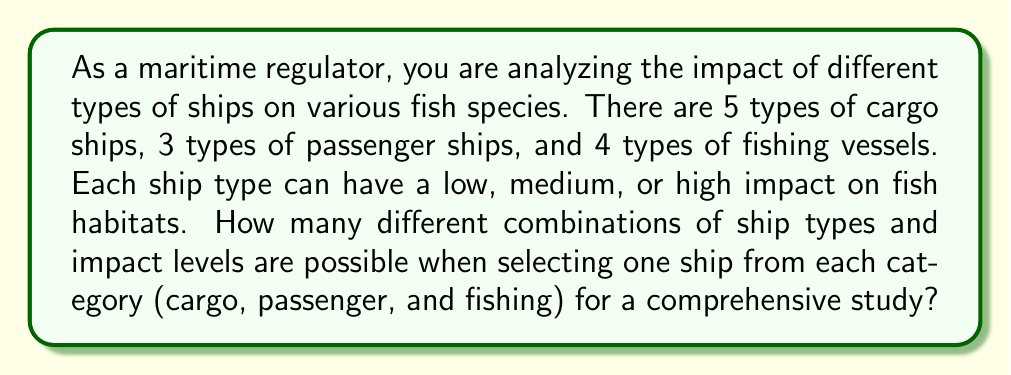Solve this math problem. To solve this problem, we need to use the multiplication principle of counting. We'll break down the problem into steps:

1. For cargo ships:
   - There are 5 types of cargo ships
   - Each ship can have 3 levels of impact (low, medium, high)
   - Total combinations for cargo ships: $5 \times 3 = 15$

2. For passenger ships:
   - There are 3 types of passenger ships
   - Each ship can have 3 levels of impact
   - Total combinations for passenger ships: $3 \times 3 = 9$

3. For fishing vessels:
   - There are 4 types of fishing vessels
   - Each vessel can have 3 levels of impact
   - Total combinations for fishing vessels: $4 \times 3 = 12$

4. To get the total number of combinations when selecting one ship from each category, we multiply the number of combinations for each category:

   $$ \text{Total combinations} = 15 \times 9 \times 12 $$

5. Calculating the final result:
   $$ 15 \times 9 \times 12 = 1,620 $$

Therefore, there are 1,620 different combinations of ship types and impact levels possible when selecting one ship from each category for the study.
Answer: 1,620 combinations 